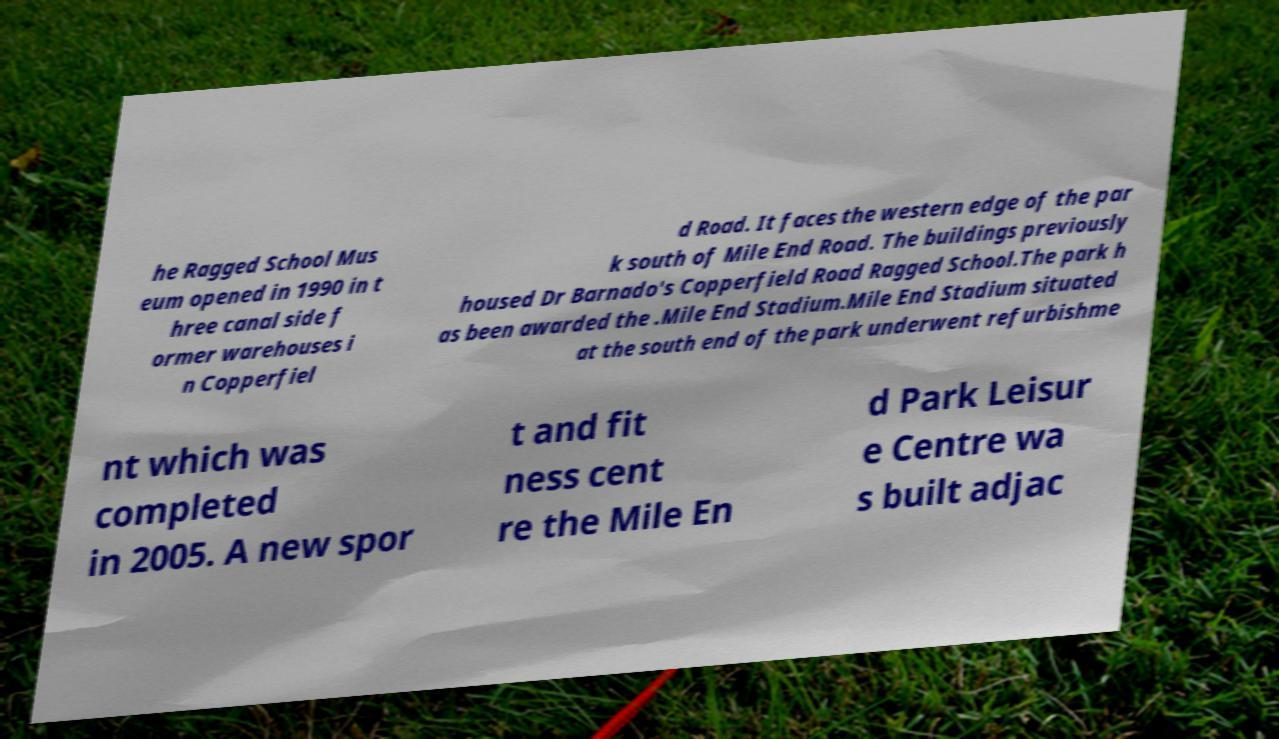Can you accurately transcribe the text from the provided image for me? he Ragged School Mus eum opened in 1990 in t hree canal side f ormer warehouses i n Copperfiel d Road. It faces the western edge of the par k south of Mile End Road. The buildings previously housed Dr Barnado's Copperfield Road Ragged School.The park h as been awarded the .Mile End Stadium.Mile End Stadium situated at the south end of the park underwent refurbishme nt which was completed in 2005. A new spor t and fit ness cent re the Mile En d Park Leisur e Centre wa s built adjac 